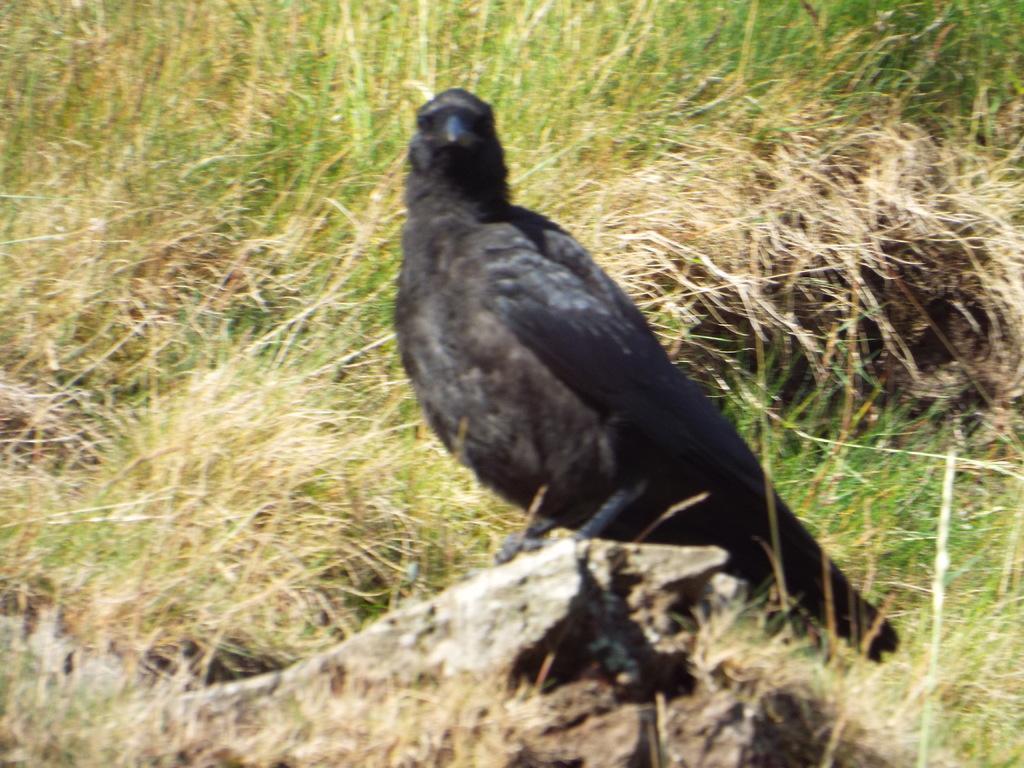Could you give a brief overview of what you see in this image? In the center of the image there is a crow on the rock. In the background of the image there is grass. 